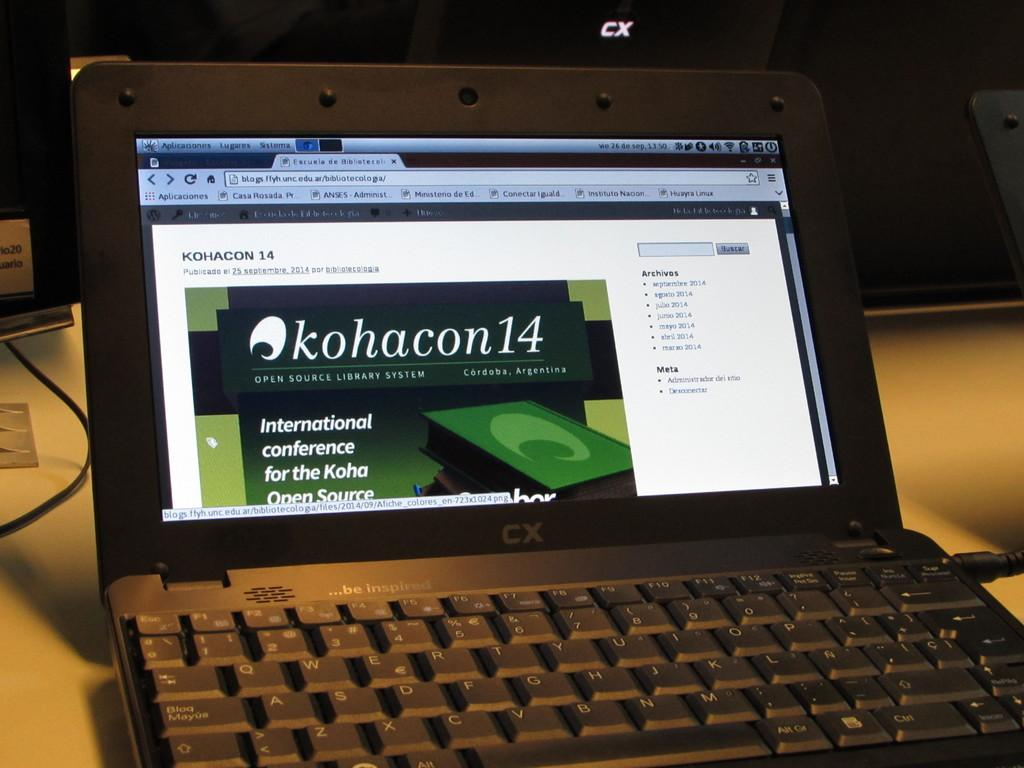<image>
Relay a brief, clear account of the picture shown. CX Laptop that says Kohacon14 on the screen and words saying International conference for the Kaha Open Source. 